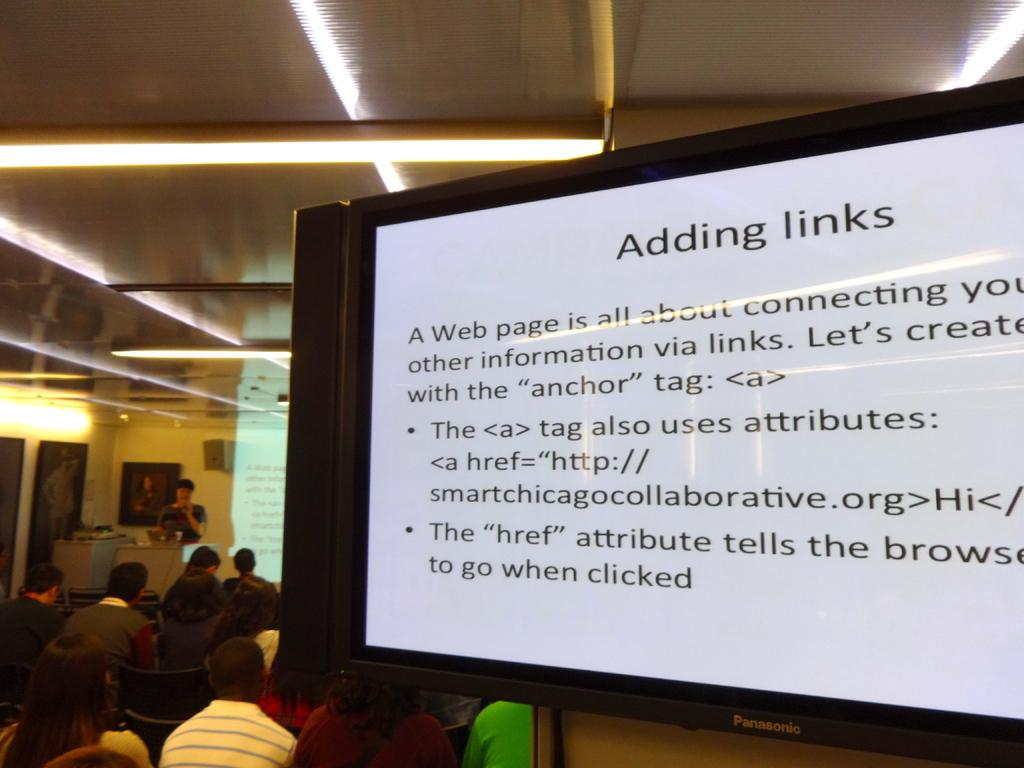What is the main object in the image? There is a hoarding board in the image. What is written or displayed on the hoarding board? There is text on the hoarding board. Are there any people present in the image? Yes, there are people visible in the image. What can be seen in terms of lighting in the image? Light is visible in the image. What type of structure is present in the background? There is a wall in the image. Is there any additional object attached to the wall? Yes, there is a photo frame attached to the wall. How many cannons are visible in the image? There are no cannons present in the image. What shape is the tent in the image? There is no tent present in the image. 